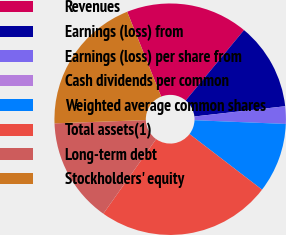<chart> <loc_0><loc_0><loc_500><loc_500><pie_chart><fcel>Revenues<fcel>Earnings (loss) from<fcel>Earnings (loss) per share from<fcel>Cash dividends per common<fcel>Weighted average common shares<fcel>Total assets(1)<fcel>Long-term debt<fcel>Stockholders' equity<nl><fcel>17.07%<fcel>12.2%<fcel>2.44%<fcel>0.0%<fcel>9.76%<fcel>24.39%<fcel>14.63%<fcel>19.51%<nl></chart> 